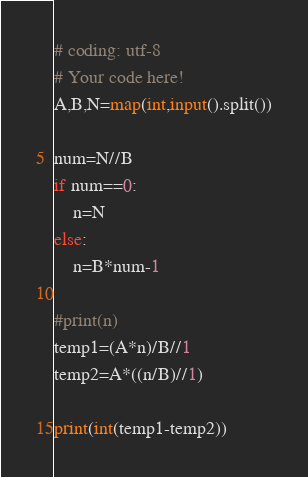<code> <loc_0><loc_0><loc_500><loc_500><_Python_># coding: utf-8
# Your code here!
A,B,N=map(int,input().split())

num=N//B
if num==0:
    n=N
else:
    n=B*num-1

#print(n)
temp1=(A*n)/B//1
temp2=A*((n/B)//1)

print(int(temp1-temp2))
</code> 